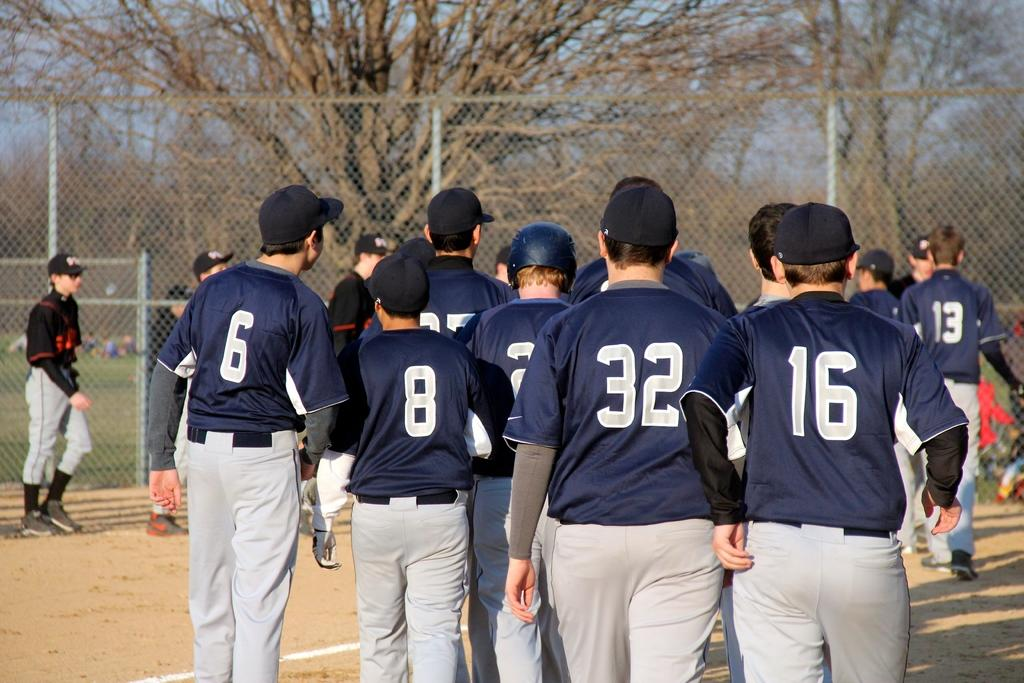<image>
Summarize the visual content of the image. Number 16 stands behind all his teammates on the field. 